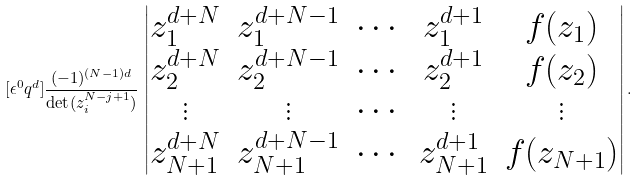<formula> <loc_0><loc_0><loc_500><loc_500>[ \epsilon ^ { 0 } q ^ { d } ] \frac { ( - 1 ) ^ { ( N - 1 ) d } } { \det ( z _ { i } ^ { N - j + 1 } ) } \, \begin{vmatrix} z _ { 1 } ^ { d + N } & z _ { 1 } ^ { d + N - 1 } & \cdots & z _ { 1 } ^ { d + 1 } & f ( z _ { 1 } ) \\ z _ { 2 } ^ { d + N } & z _ { 2 } ^ { d + N - 1 } & \cdots & z _ { 2 } ^ { d + 1 } & f ( z _ { 2 } ) \\ \vdots & \vdots & \cdots & \vdots & \vdots \\ z _ { N + 1 } ^ { d + N } & z _ { N + 1 } ^ { d + N - 1 } & \cdots & z _ { N + 1 } ^ { d + 1 } & f ( z _ { N + 1 } ) \end{vmatrix} .</formula> 